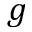Convert formula to latex. <formula><loc_0><loc_0><loc_500><loc_500>g</formula> 